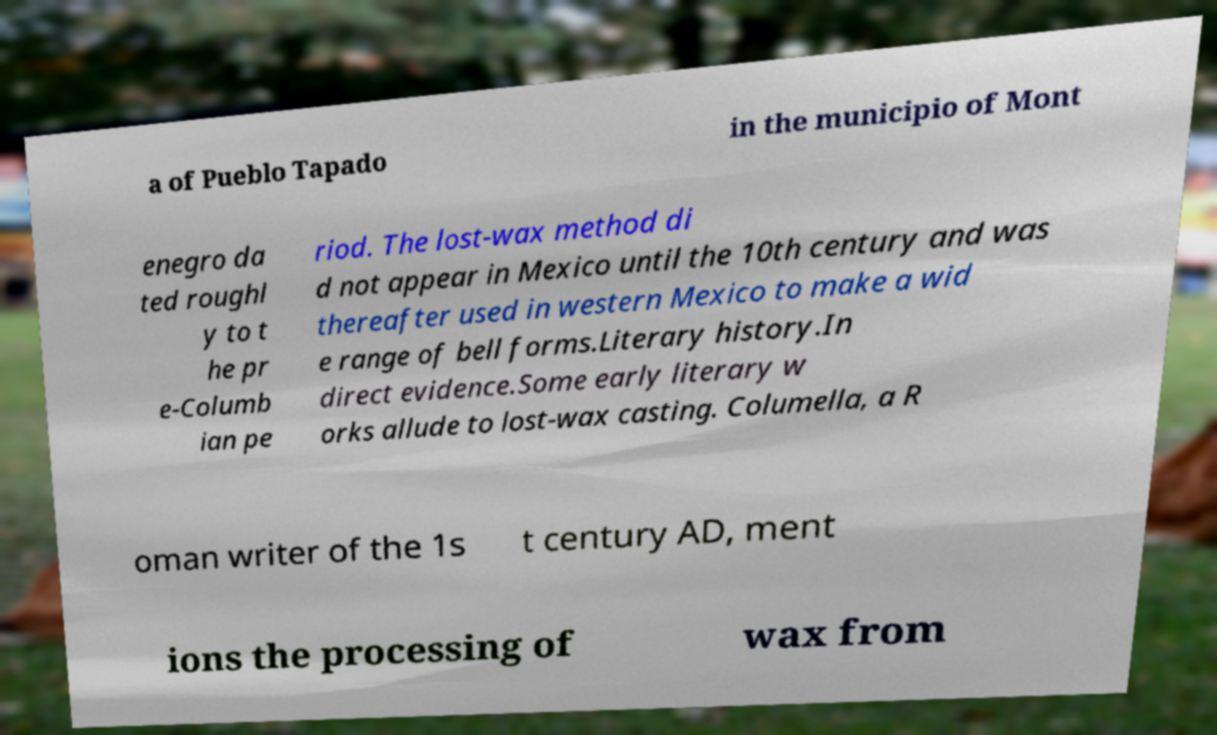Can you read and provide the text displayed in the image?This photo seems to have some interesting text. Can you extract and type it out for me? a of Pueblo Tapado in the municipio of Mont enegro da ted roughl y to t he pr e-Columb ian pe riod. The lost-wax method di d not appear in Mexico until the 10th century and was thereafter used in western Mexico to make a wid e range of bell forms.Literary history.In direct evidence.Some early literary w orks allude to lost-wax casting. Columella, a R oman writer of the 1s t century AD, ment ions the processing of wax from 